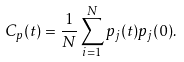<formula> <loc_0><loc_0><loc_500><loc_500>C _ { p } ( t ) = \frac { 1 } { N } \sum _ { i = 1 } ^ { N } p _ { j } ( t ) p _ { j } ( 0 ) .</formula> 